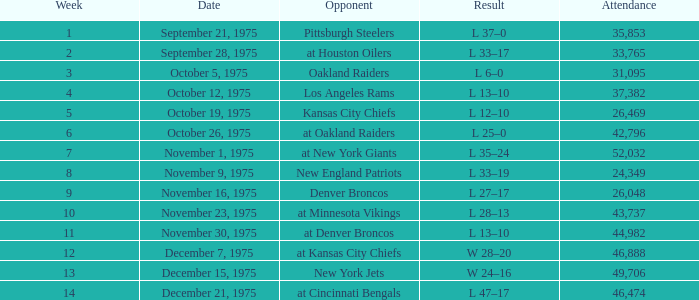What is the average Week when the result was w 28–20, and there were more than 46,888 in attendance? None. 